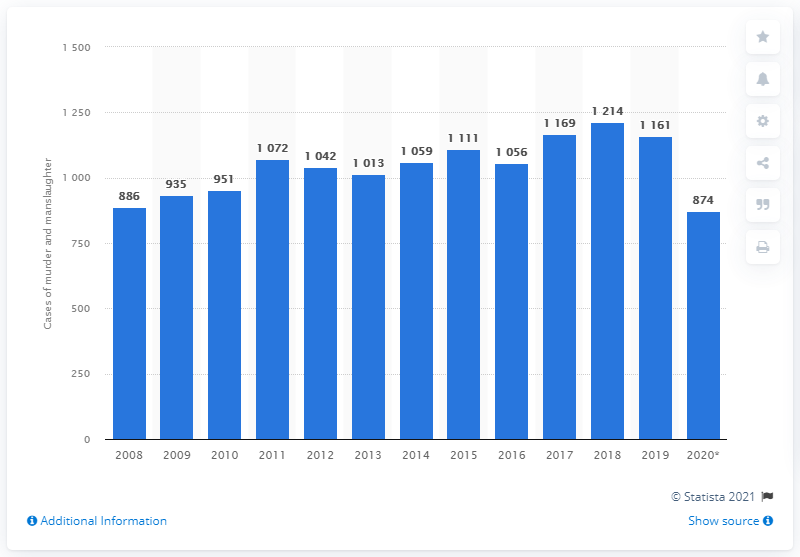Highlight a few significant elements in this photo. In 2020, 874 murders and manslaughters were recorded by the Belgian police. 